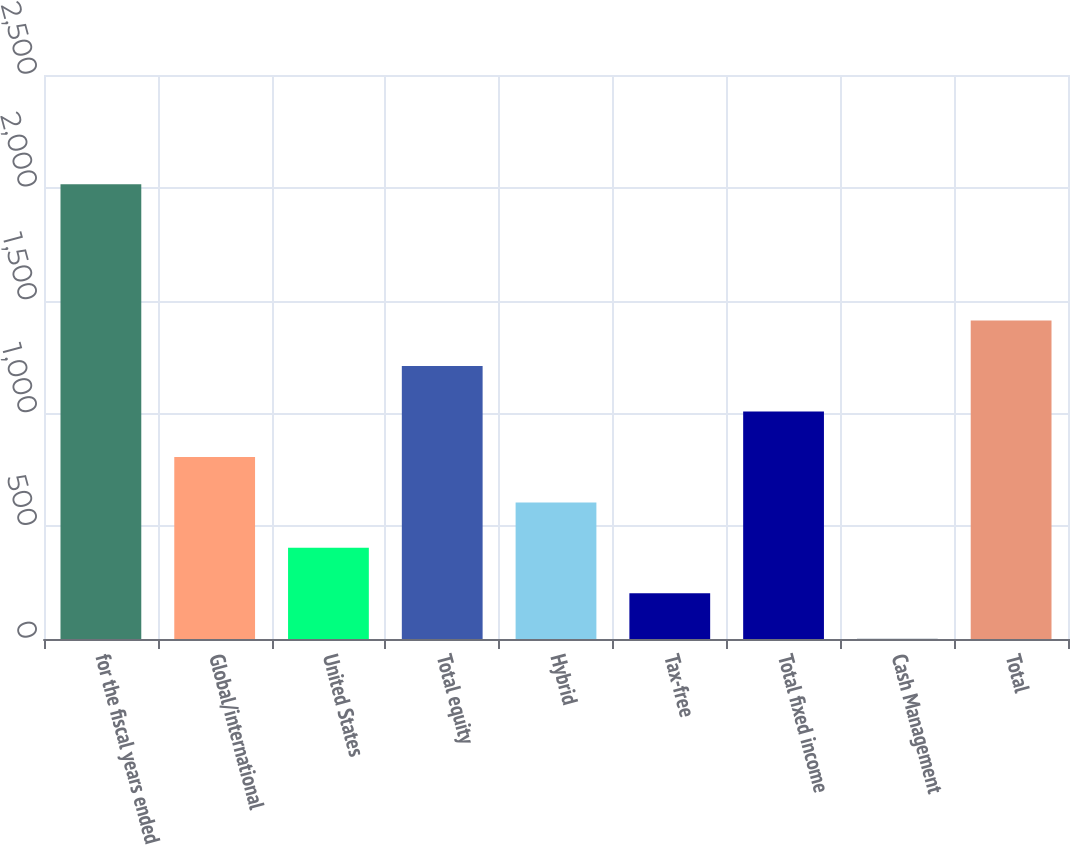Convert chart. <chart><loc_0><loc_0><loc_500><loc_500><bar_chart><fcel>for the fiscal years ended<fcel>Global/international<fcel>United States<fcel>Total equity<fcel>Hybrid<fcel>Tax-free<fcel>Total fixed income<fcel>Cash Management<fcel>Total<nl><fcel>2016<fcel>807<fcel>404<fcel>1210<fcel>605.5<fcel>202.5<fcel>1008.5<fcel>1<fcel>1411.5<nl></chart> 